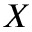<formula> <loc_0><loc_0><loc_500><loc_500>X</formula> 